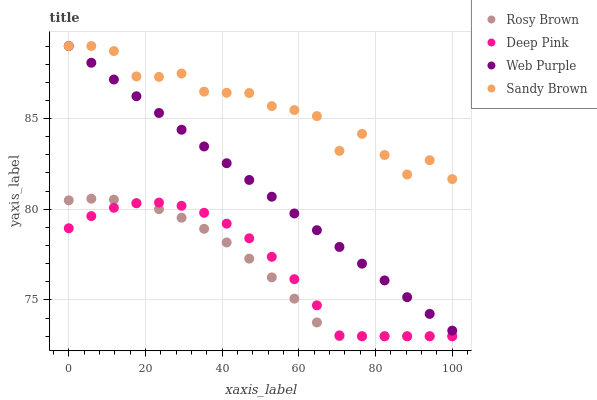Does Rosy Brown have the minimum area under the curve?
Answer yes or no. Yes. Does Sandy Brown have the maximum area under the curve?
Answer yes or no. Yes. Does Sandy Brown have the minimum area under the curve?
Answer yes or no. No. Does Rosy Brown have the maximum area under the curve?
Answer yes or no. No. Is Web Purple the smoothest?
Answer yes or no. Yes. Is Sandy Brown the roughest?
Answer yes or no. Yes. Is Rosy Brown the smoothest?
Answer yes or no. No. Is Rosy Brown the roughest?
Answer yes or no. No. Does Rosy Brown have the lowest value?
Answer yes or no. Yes. Does Sandy Brown have the lowest value?
Answer yes or no. No. Does Sandy Brown have the highest value?
Answer yes or no. Yes. Does Rosy Brown have the highest value?
Answer yes or no. No. Is Rosy Brown less than Web Purple?
Answer yes or no. Yes. Is Web Purple greater than Rosy Brown?
Answer yes or no. Yes. Does Deep Pink intersect Rosy Brown?
Answer yes or no. Yes. Is Deep Pink less than Rosy Brown?
Answer yes or no. No. Is Deep Pink greater than Rosy Brown?
Answer yes or no. No. Does Rosy Brown intersect Web Purple?
Answer yes or no. No. 